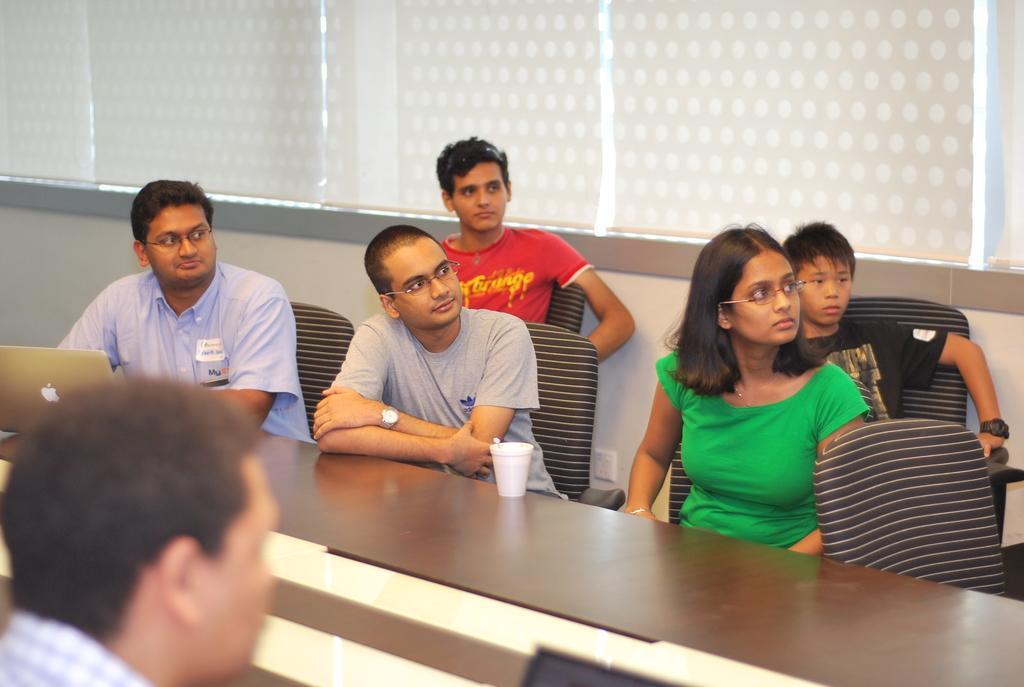Could you give a brief overview of what you see in this image? In this picture we can see some people sitting on chairs in front of a desk, we can see a glass and a laptop on the desk, in the background there are window blinds. 